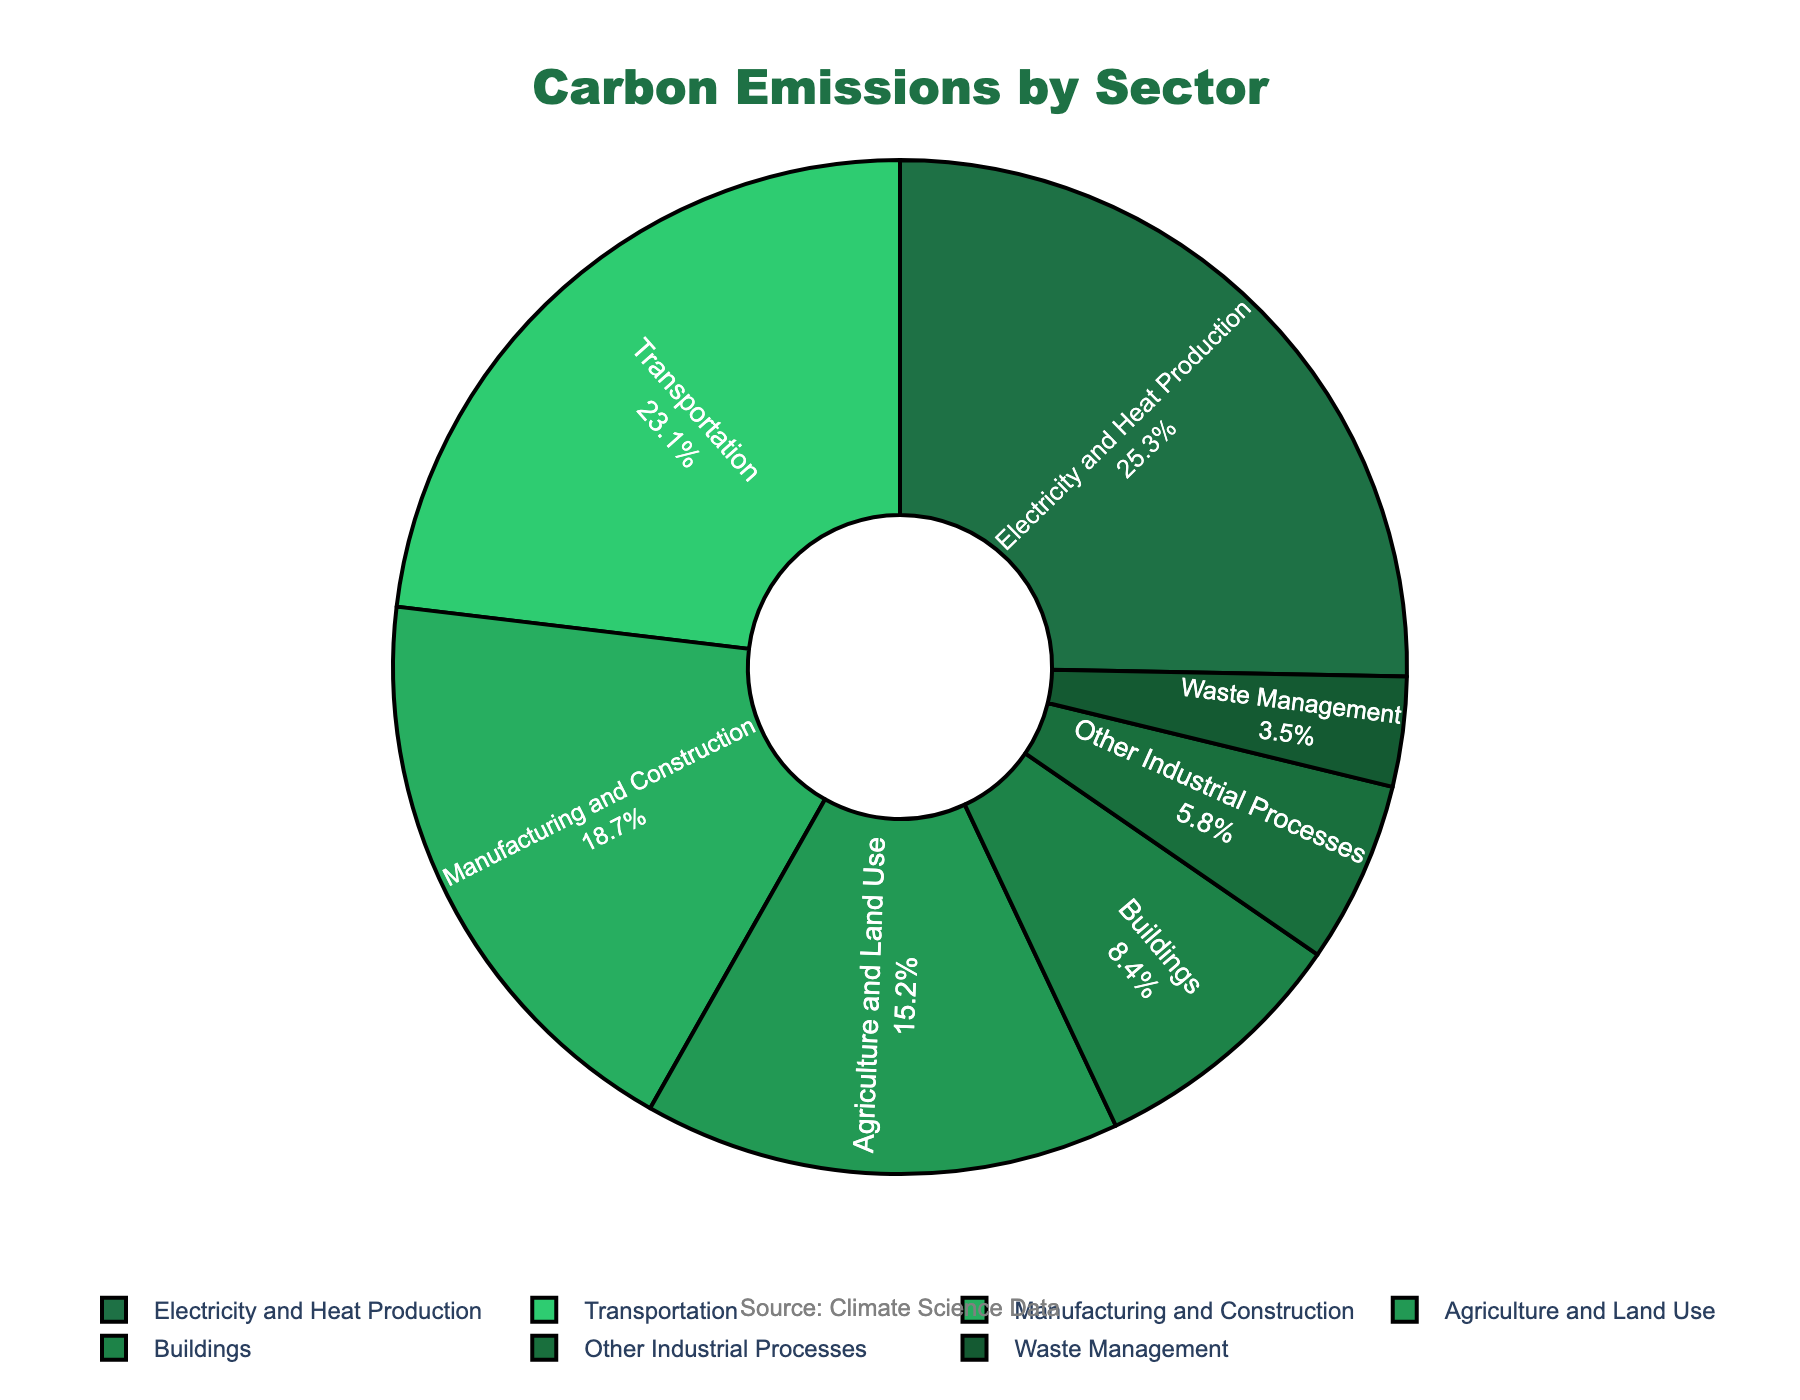What sector has the largest percentage of carbon emissions? To find the sector with the largest percentage, look for the segment with the highest numerical value or the largest visual area in the pie chart. The sector with 25.3% (Electricity and Heat Production) clearly stands out.
Answer: Electricity and Heat Production Which two sectors contribute more than half of the total carbon emissions? Add the percentages of the different sectors until you exceed 50%. Electricity and Heat Production (25.3%) and Transportation (23.1%) together sum to 48.4%. Including Manufacturing and Construction (18.7%) makes the total 67.1%. The first two sectors alone exceed half of the emissions.
Answer: Electricity and Heat Production and Transportation What is the difference in the percentage of emissions between Transportation and Buildings? Subtract the percentage for Buildings from the percentage for Transportation: 23.1% - 8.4% = 14.7%.
Answer: 14.7% How much more do Manufacturing and Construction contribute compared to Other Industrial Processes? Subtract the percentage for Other Industrial Processes from the percentage for Manufacturing and Construction: 18.7% - 5.8% = 12.9%.
Answer: 12.9% What is the combined percentage of the three smallest sectors? Sum the percentages of the three smallest sectors: Buildings (8.4%), Other Industrial Processes (5.8%), and Waste Management (3.5%): 8.4% + 5.8% + 3.5% = 17.7%.
Answer: 17.7% Which sector has the smallest share of carbon emissions? Identify the sector with the smallest percentage. Waste Management has the lowest value at 3.5%.
Answer: Waste Management What is the average percentage of carbon emissions for all sectors? Sum all the percentages and divide by the number of sectors: (25.3 + 23.1 + 18.7 + 15.2 + 8.4 + 5.8 + 3.5) / 7 ≈ 14.28%.
Answer: 14.28% Are the emissions from Agriculture and Land Use higher or lower than those from Manufacturing and Construction? Compare the percentages: Agriculture and Land Use (15.2%) and Manufacturing and Construction (18.7%). 15.2% is less than 18.7%.
Answer: Lower What percentage of emissions do sectors other than Electricity and Heat Production contribute? Subtract the percentage for Electricity and Heat Production from 100%: 100% - 25.3% = 74.7%.
Answer: 74.7% Which sector’s percentage is closest to one-fifth of the total emissions? One-fifth of 100% is 20%. Compare the percentages in the list to 20%. Manufacturing and Construction at 18.7% is closest to 20%.
Answer: Manufacturing and Construction 